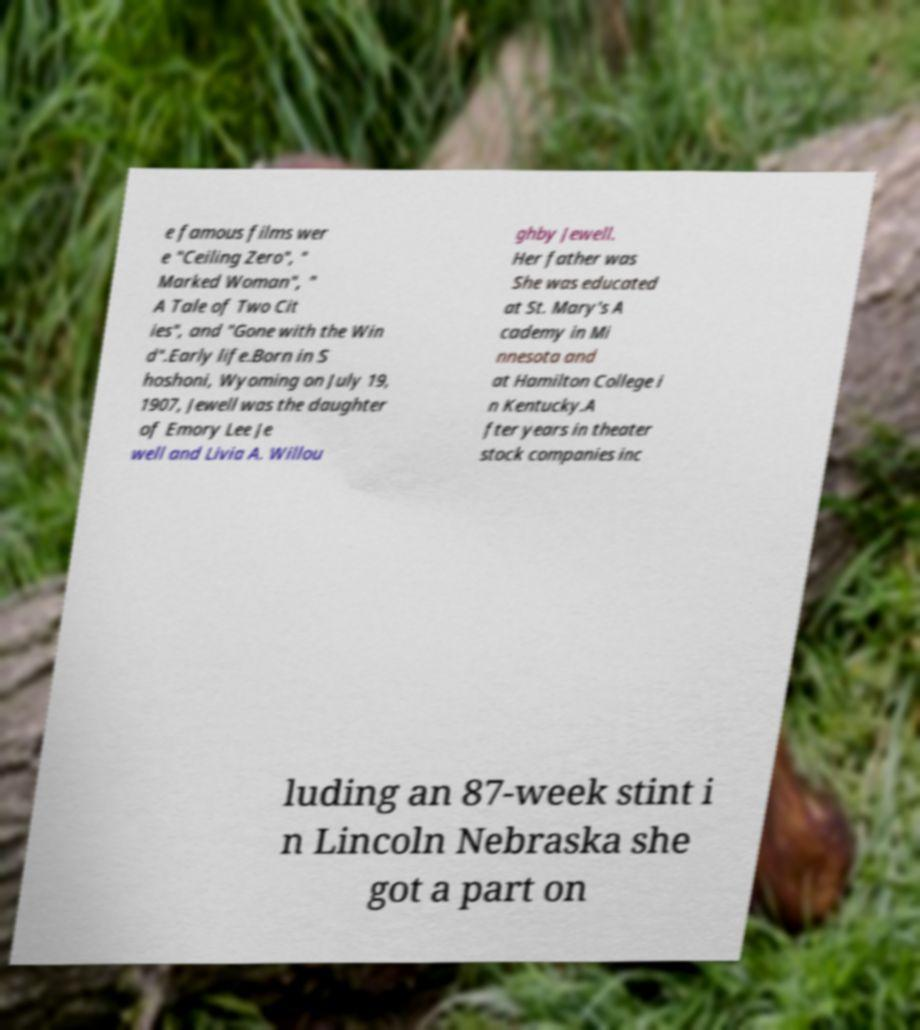There's text embedded in this image that I need extracted. Can you transcribe it verbatim? e famous films wer e "Ceiling Zero", " Marked Woman", " A Tale of Two Cit ies", and "Gone with the Win d".Early life.Born in S hoshoni, Wyoming on July 19, 1907, Jewell was the daughter of Emory Lee Je well and Livia A. Willou ghby Jewell. Her father was She was educated at St. Mary's A cademy in Mi nnesota and at Hamilton College i n Kentucky.A fter years in theater stock companies inc luding an 87-week stint i n Lincoln Nebraska she got a part on 